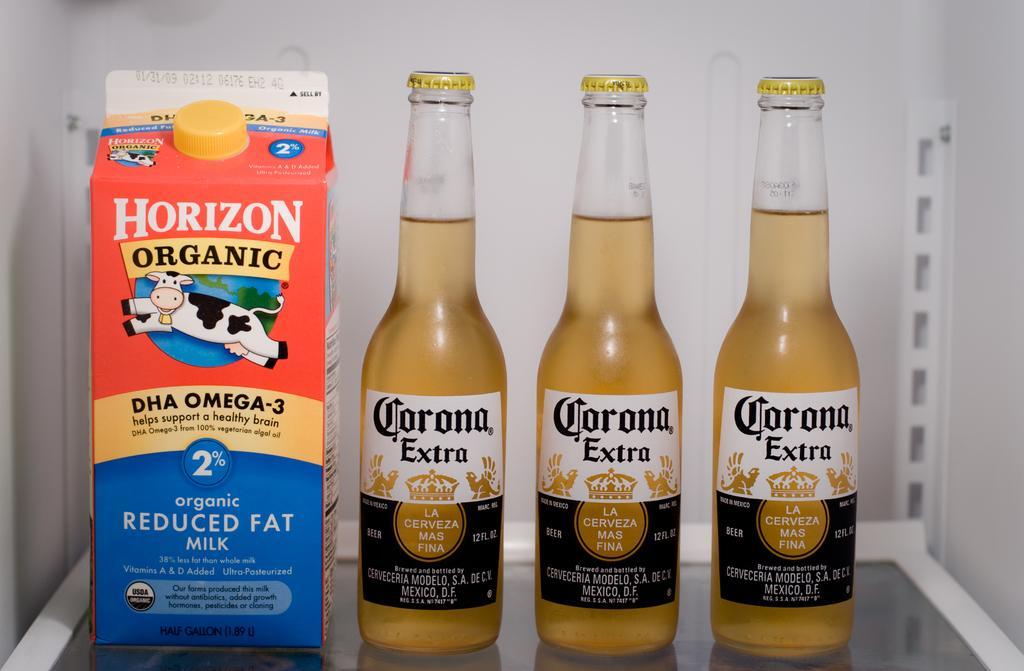Could you give a brief overview of what you see in this image? In this image there are three bottles and an object on the table, there are labels to the bottles and the wall. 